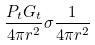<formula> <loc_0><loc_0><loc_500><loc_500>\frac { P _ { t } G _ { t } } { 4 \pi r ^ { 2 } } \sigma \frac { 1 } { 4 \pi r ^ { 2 } }</formula> 